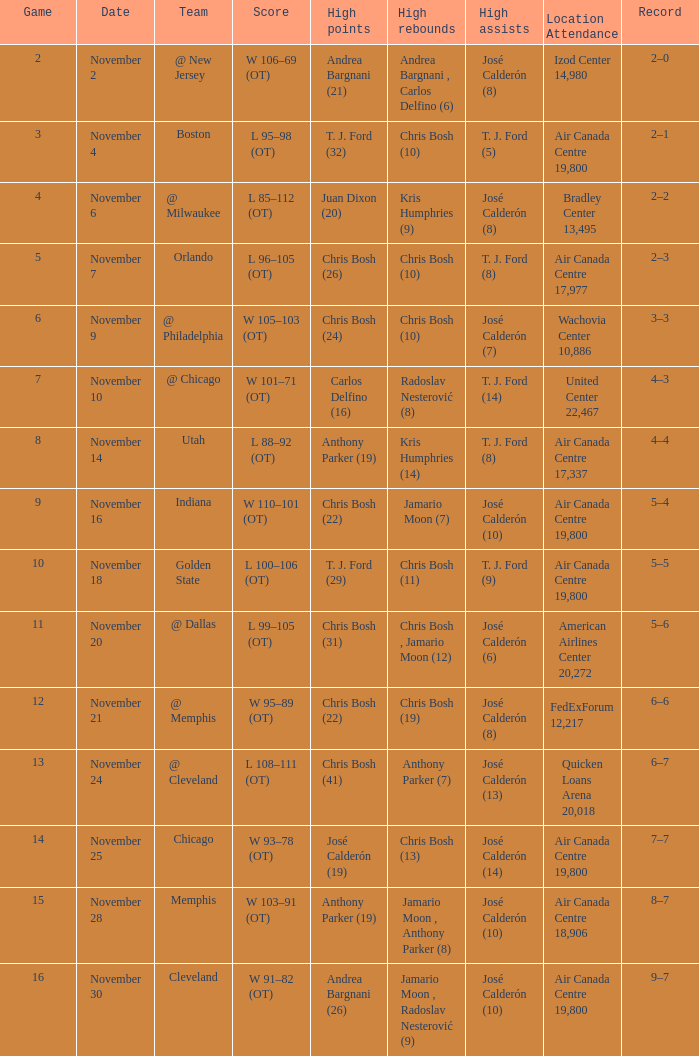Who secured the highest rebounds when it came to game 6? Chris Bosh (10). 